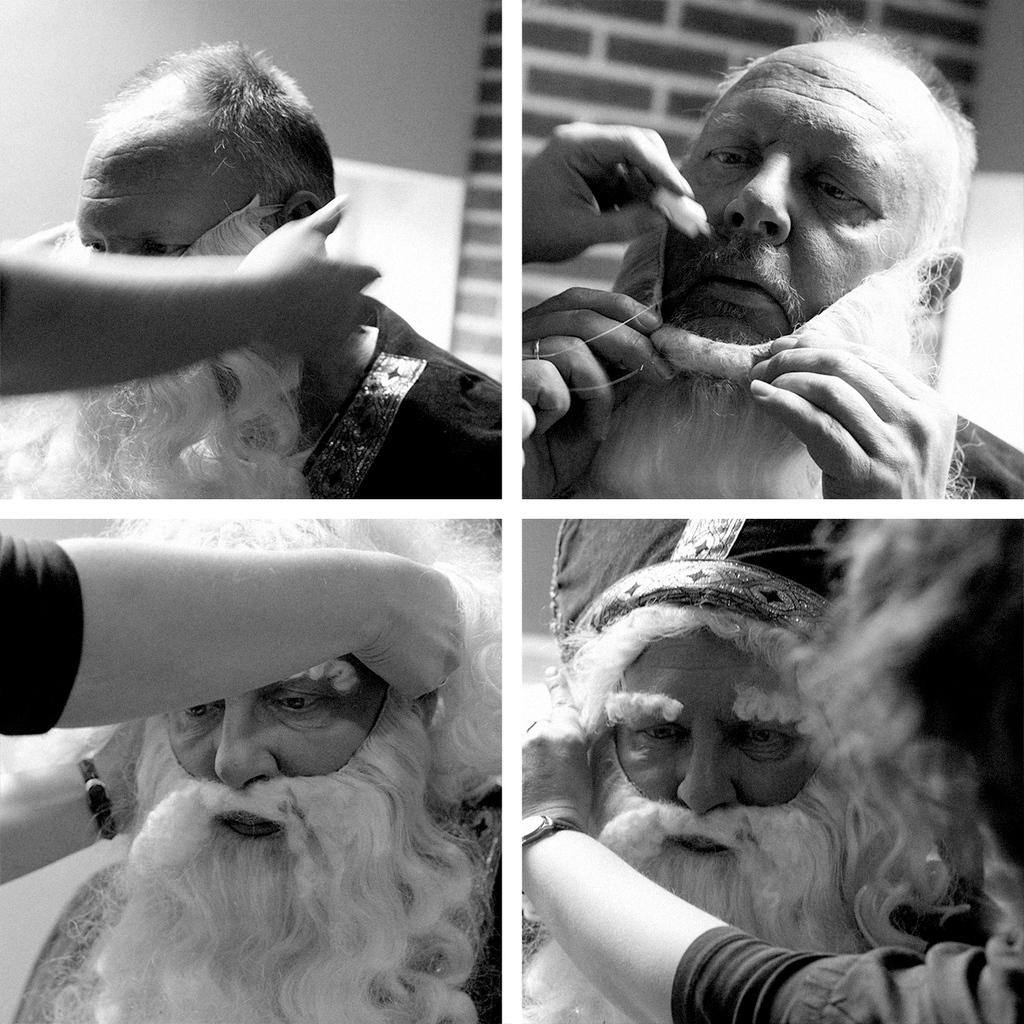What is the style of the image? The image is a black and white collage. Can you describe the main subject of the image? There is a man in the image. What is the man wearing? The man is wearing a getup. Reasoning: Let's think step by identifying the main subjects and objects in the image based on the provided facts. We then formulate questions that focus on the style, main subject, and specific details about the man in the image. We avoid yes/no questions and ensure that the language is simple and clear. Absurd Question/Answer: What type of government is depicted in the image? There is no depiction of a government in the image; it features a man in a black and white collage. How does the hose contribute to the image? There is no hose present in the image. What type of government is depicted in the image? There is no depiction of a government in the image; it features a man in a black and white collage. How does the hose contribute to the image? There is no hose present in the image. 